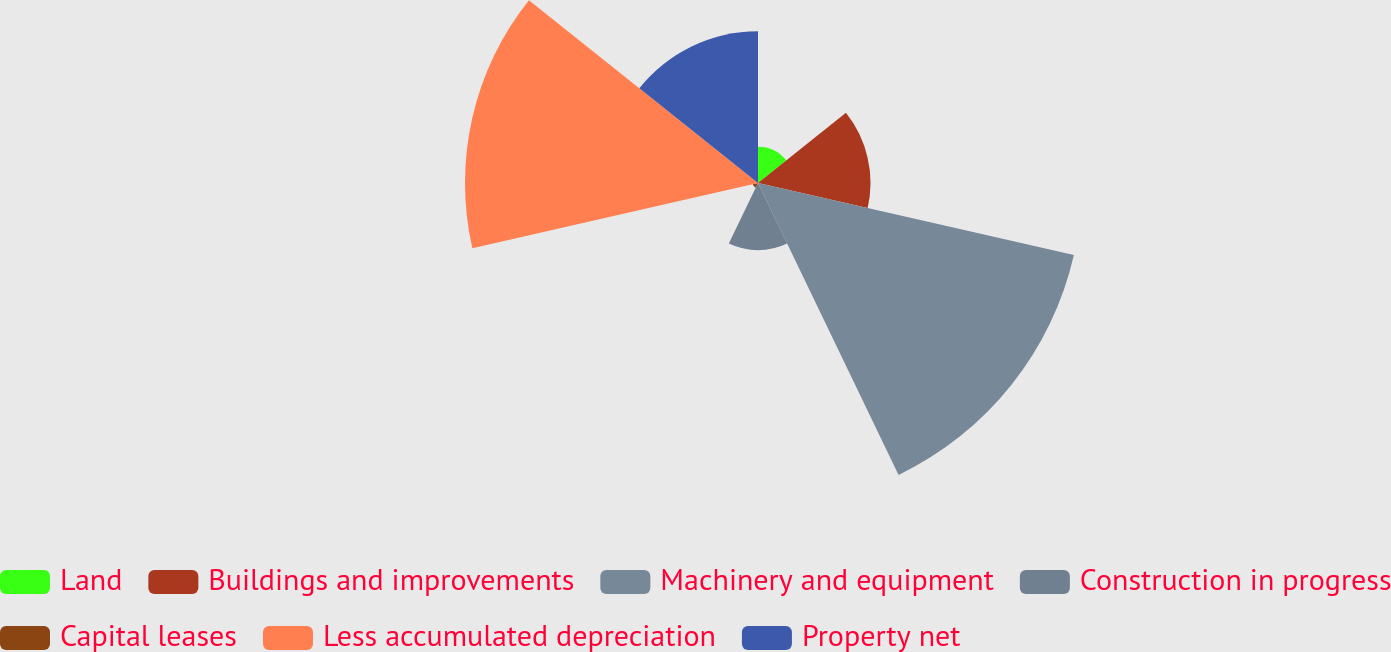Convert chart. <chart><loc_0><loc_0><loc_500><loc_500><pie_chart><fcel>Land<fcel>Buildings and improvements<fcel>Machinery and equipment<fcel>Construction in progress<fcel>Capital leases<fcel>Less accumulated depreciation<fcel>Property net<nl><fcel>3.67%<fcel>11.36%<fcel>32.72%<fcel>6.79%<fcel>0.54%<fcel>29.59%<fcel>15.33%<nl></chart> 